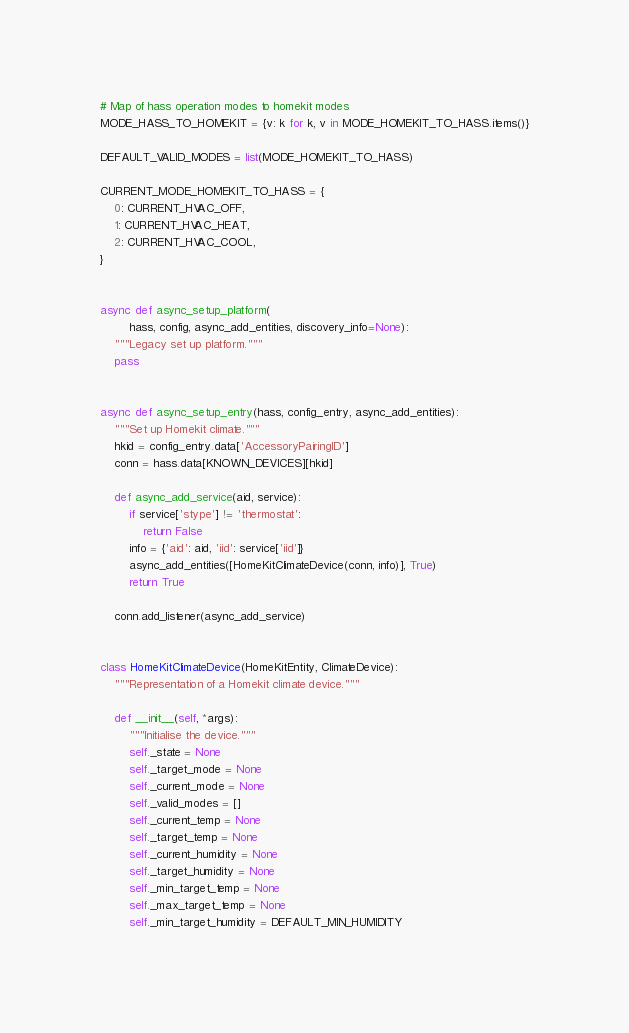<code> <loc_0><loc_0><loc_500><loc_500><_Python_># Map of hass operation modes to homekit modes
MODE_HASS_TO_HOMEKIT = {v: k for k, v in MODE_HOMEKIT_TO_HASS.items()}

DEFAULT_VALID_MODES = list(MODE_HOMEKIT_TO_HASS)

CURRENT_MODE_HOMEKIT_TO_HASS = {
    0: CURRENT_HVAC_OFF,
    1: CURRENT_HVAC_HEAT,
    2: CURRENT_HVAC_COOL,
}


async def async_setup_platform(
        hass, config, async_add_entities, discovery_info=None):
    """Legacy set up platform."""
    pass


async def async_setup_entry(hass, config_entry, async_add_entities):
    """Set up Homekit climate."""
    hkid = config_entry.data['AccessoryPairingID']
    conn = hass.data[KNOWN_DEVICES][hkid]

    def async_add_service(aid, service):
        if service['stype'] != 'thermostat':
            return False
        info = {'aid': aid, 'iid': service['iid']}
        async_add_entities([HomeKitClimateDevice(conn, info)], True)
        return True

    conn.add_listener(async_add_service)


class HomeKitClimateDevice(HomeKitEntity, ClimateDevice):
    """Representation of a Homekit climate device."""

    def __init__(self, *args):
        """Initialise the device."""
        self._state = None
        self._target_mode = None
        self._current_mode = None
        self._valid_modes = []
        self._current_temp = None
        self._target_temp = None
        self._current_humidity = None
        self._target_humidity = None
        self._min_target_temp = None
        self._max_target_temp = None
        self._min_target_humidity = DEFAULT_MIN_HUMIDITY</code> 